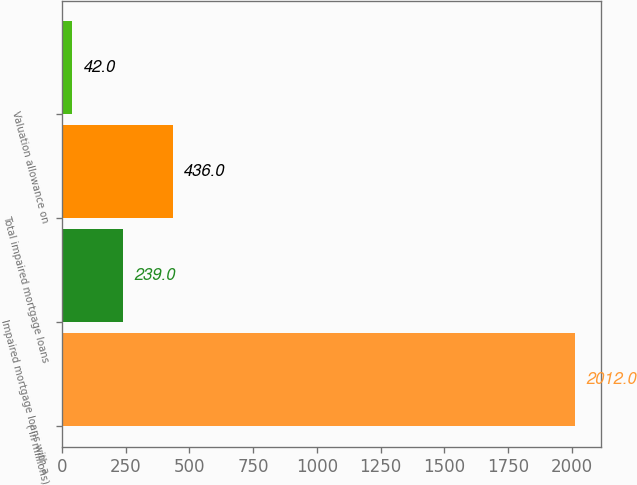<chart> <loc_0><loc_0><loc_500><loc_500><bar_chart><fcel>( in millions)<fcel>Impaired mortgage loans with a<fcel>Total impaired mortgage loans<fcel>Valuation allowance on<nl><fcel>2012<fcel>239<fcel>436<fcel>42<nl></chart> 